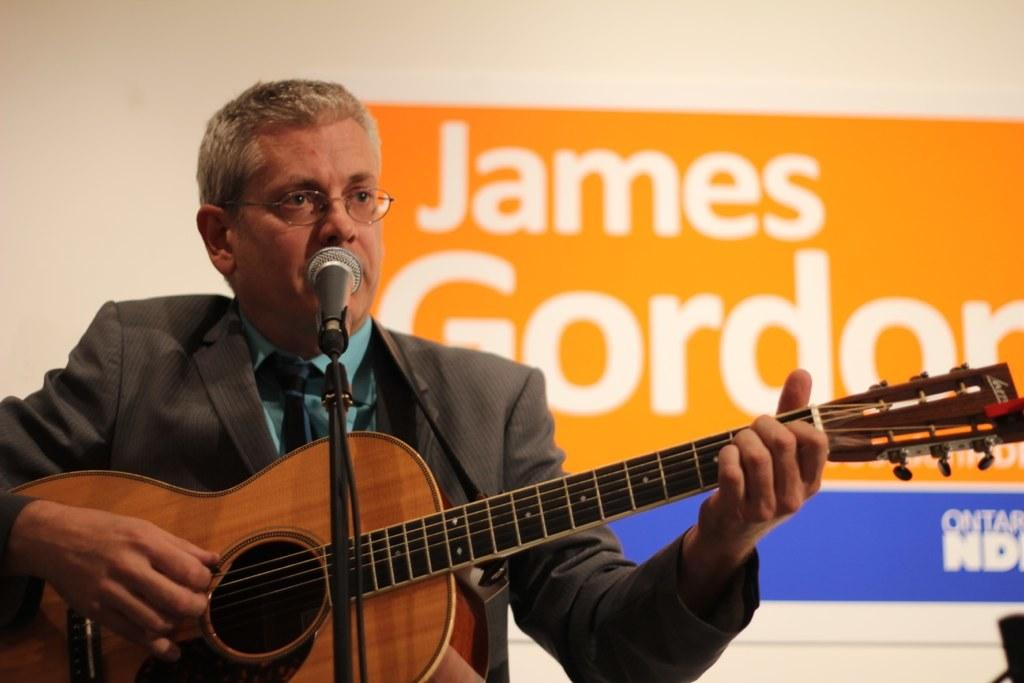What is the person in the image doing? The person in the image is playing a guitar. What object is in front of the person? There is a microphone in front of the person. What type of wax is being used by the committee in the image? There is no committee or wax present in the image; it features a person playing a guitar with a microphone in front of them. 